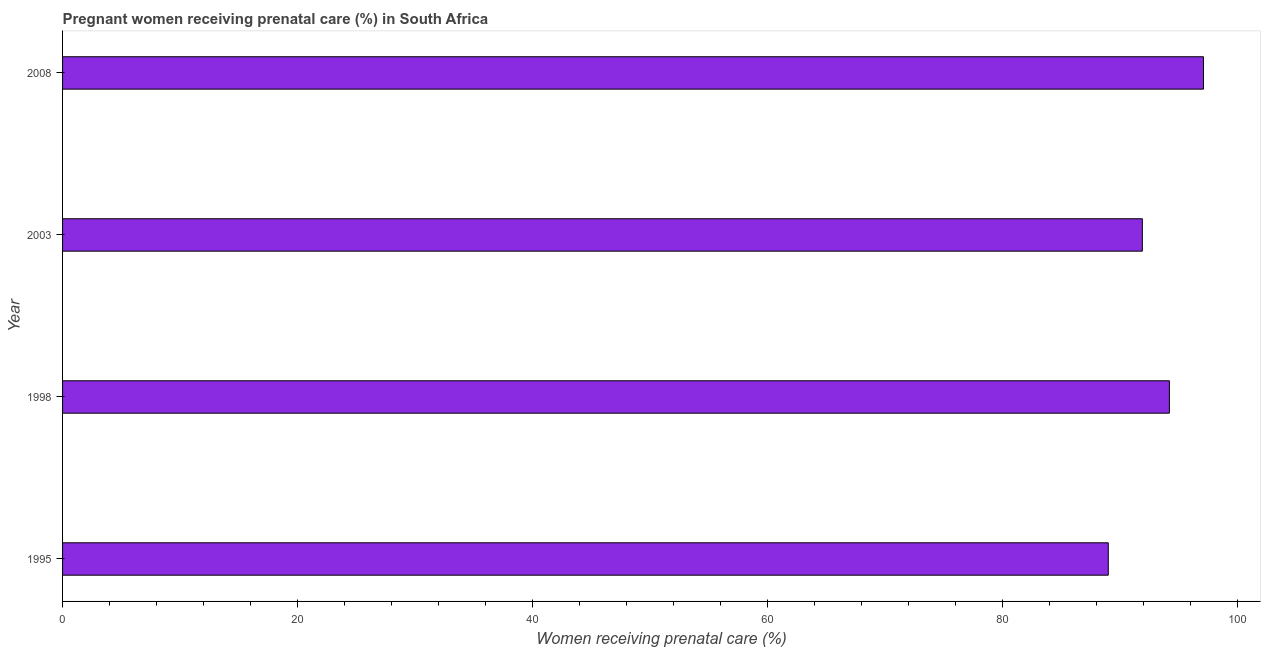Does the graph contain any zero values?
Provide a short and direct response. No. Does the graph contain grids?
Ensure brevity in your answer.  No. What is the title of the graph?
Your answer should be very brief. Pregnant women receiving prenatal care (%) in South Africa. What is the label or title of the X-axis?
Provide a short and direct response. Women receiving prenatal care (%). What is the label or title of the Y-axis?
Keep it short and to the point. Year. What is the percentage of pregnant women receiving prenatal care in 2003?
Your answer should be compact. 91.9. Across all years, what is the maximum percentage of pregnant women receiving prenatal care?
Provide a succinct answer. 97.1. Across all years, what is the minimum percentage of pregnant women receiving prenatal care?
Ensure brevity in your answer.  89. In which year was the percentage of pregnant women receiving prenatal care maximum?
Provide a succinct answer. 2008. What is the sum of the percentage of pregnant women receiving prenatal care?
Ensure brevity in your answer.  372.2. What is the average percentage of pregnant women receiving prenatal care per year?
Give a very brief answer. 93.05. What is the median percentage of pregnant women receiving prenatal care?
Your answer should be compact. 93.05. Do a majority of the years between 2003 and 1998 (inclusive) have percentage of pregnant women receiving prenatal care greater than 96 %?
Provide a short and direct response. No. What is the ratio of the percentage of pregnant women receiving prenatal care in 2003 to that in 2008?
Your answer should be compact. 0.95. Is the difference between the percentage of pregnant women receiving prenatal care in 1998 and 2008 greater than the difference between any two years?
Ensure brevity in your answer.  No. What is the difference between the highest and the lowest percentage of pregnant women receiving prenatal care?
Your answer should be compact. 8.1. In how many years, is the percentage of pregnant women receiving prenatal care greater than the average percentage of pregnant women receiving prenatal care taken over all years?
Your response must be concise. 2. How many years are there in the graph?
Your answer should be very brief. 4. What is the Women receiving prenatal care (%) of 1995?
Keep it short and to the point. 89. What is the Women receiving prenatal care (%) of 1998?
Offer a very short reply. 94.2. What is the Women receiving prenatal care (%) in 2003?
Your answer should be very brief. 91.9. What is the Women receiving prenatal care (%) of 2008?
Make the answer very short. 97.1. What is the difference between the Women receiving prenatal care (%) in 1995 and 2003?
Your response must be concise. -2.9. What is the difference between the Women receiving prenatal care (%) in 1995 and 2008?
Your answer should be compact. -8.1. What is the difference between the Women receiving prenatal care (%) in 1998 and 2008?
Offer a terse response. -2.9. What is the ratio of the Women receiving prenatal care (%) in 1995 to that in 1998?
Keep it short and to the point. 0.94. What is the ratio of the Women receiving prenatal care (%) in 1995 to that in 2003?
Your answer should be compact. 0.97. What is the ratio of the Women receiving prenatal care (%) in 1995 to that in 2008?
Provide a short and direct response. 0.92. What is the ratio of the Women receiving prenatal care (%) in 1998 to that in 2003?
Your response must be concise. 1.02. What is the ratio of the Women receiving prenatal care (%) in 2003 to that in 2008?
Give a very brief answer. 0.95. 